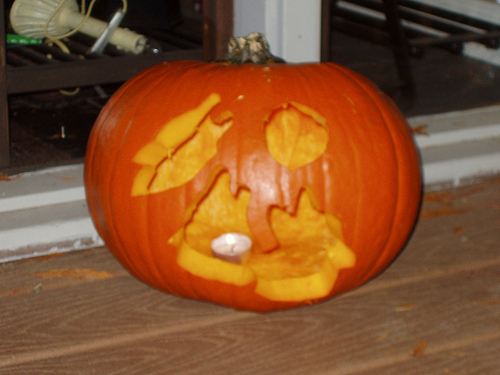<image>
Can you confirm if the candle is in the pumpkin? Yes. The candle is contained within or inside the pumpkin, showing a containment relationship. 